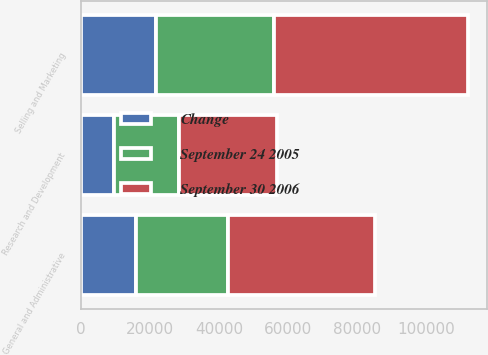Convert chart. <chart><loc_0><loc_0><loc_500><loc_500><stacked_bar_chart><ecel><fcel>Research and Development<fcel>Selling and Marketing<fcel>General and Administrative<nl><fcel>September 30 2006<fcel>28294<fcel>55910<fcel>42551<nl><fcel>September 24 2005<fcel>18617<fcel>34199<fcel>26667<nl><fcel>Change<fcel>9677<fcel>21711<fcel>15884<nl></chart> 